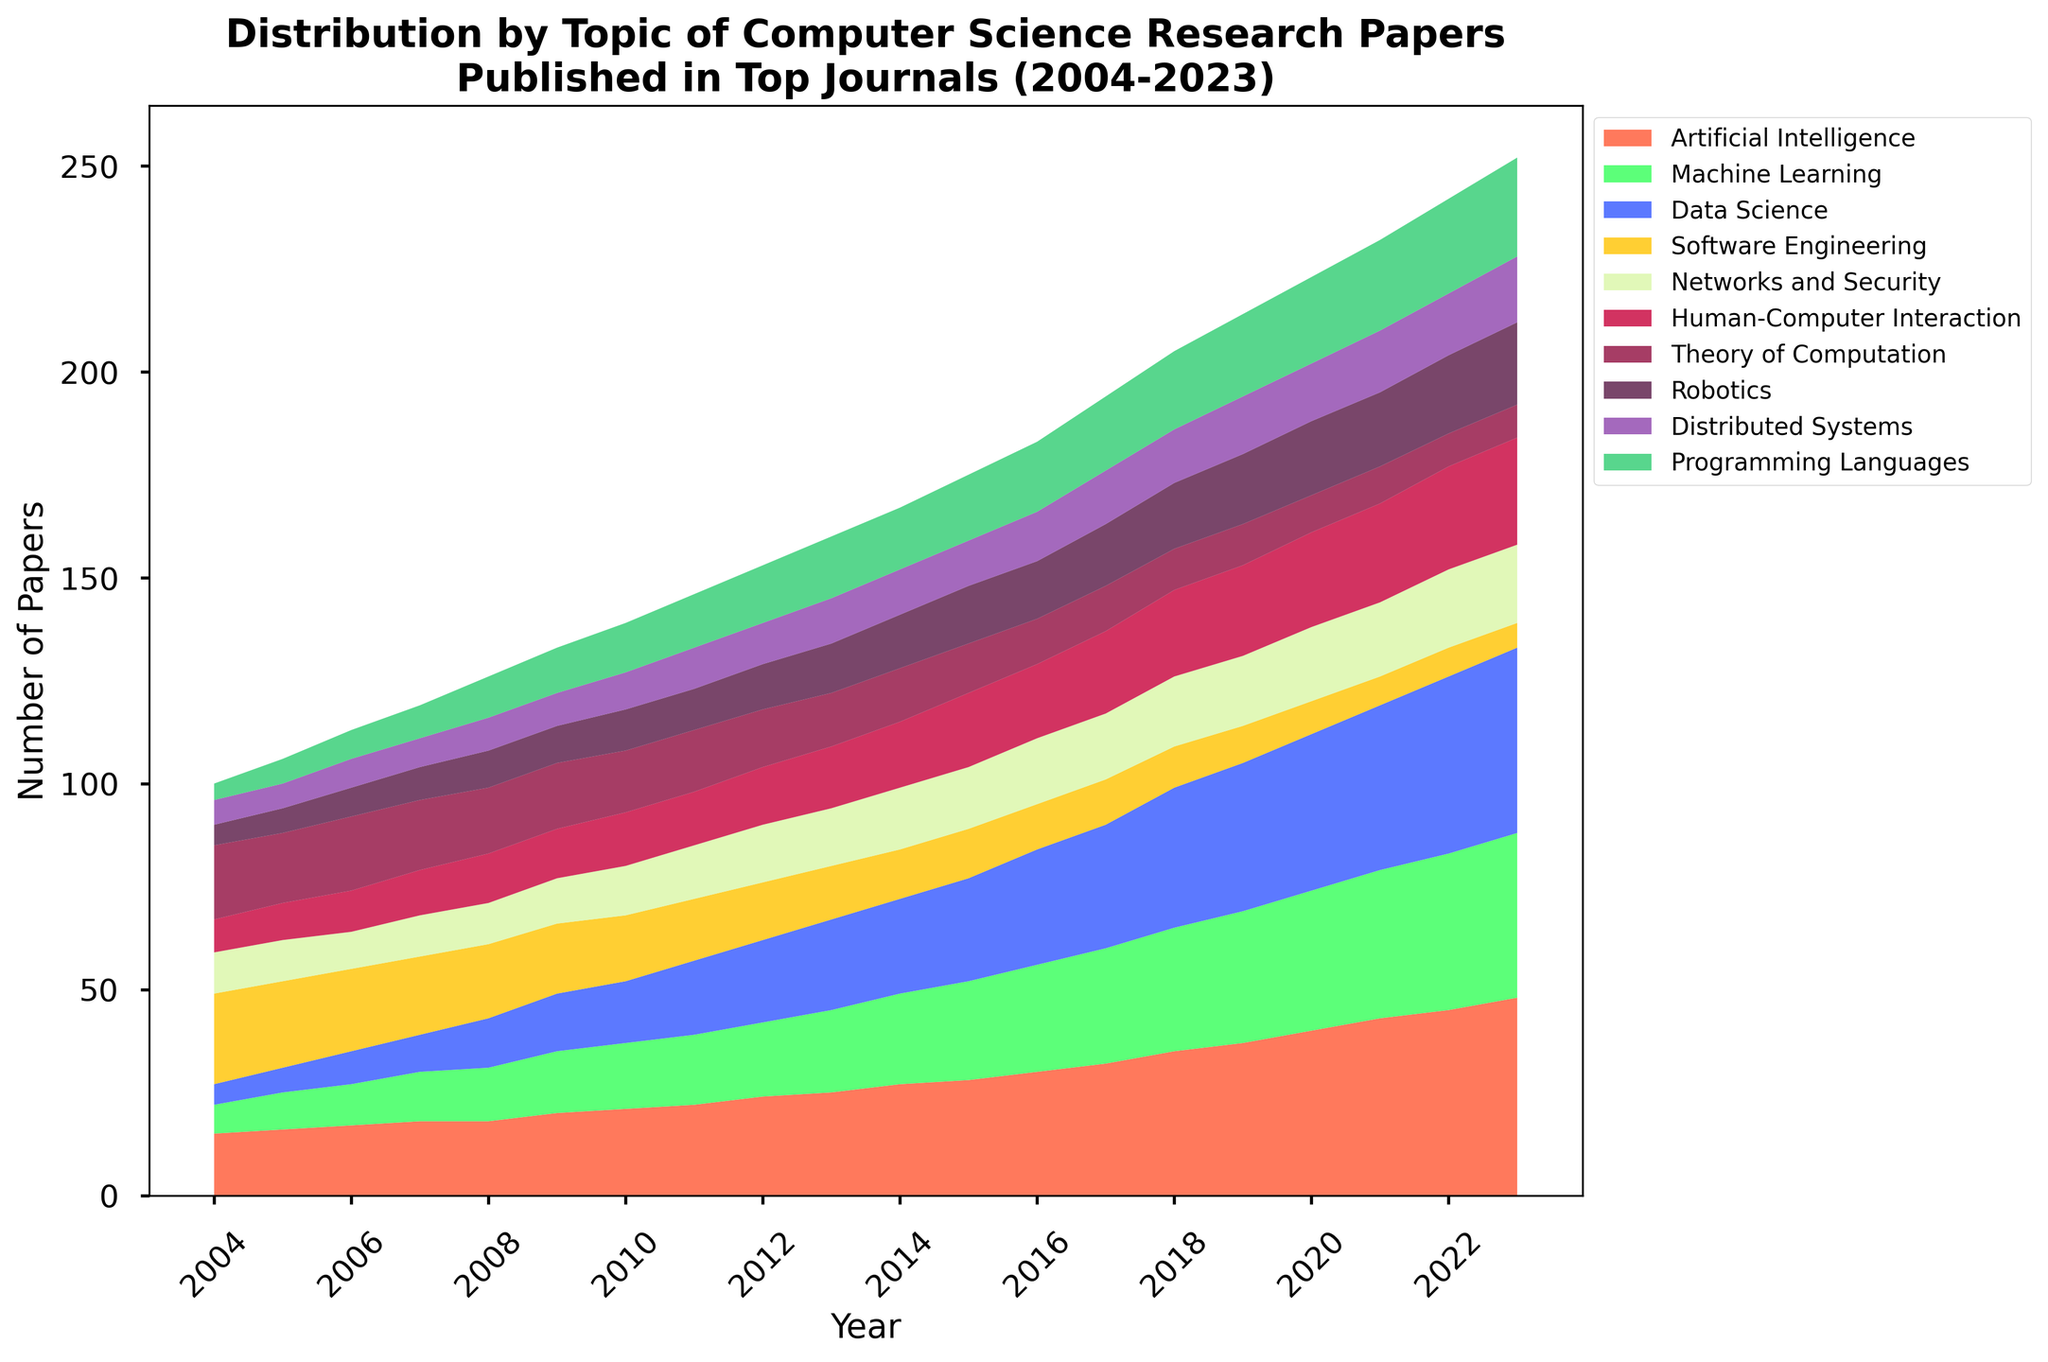What is the general trend in the number of papers related to Artificial Intelligence over the years? From 2004 to 2023, the number of papers related to Artificial Intelligence consistently increases each year, showing a clear upward trend. The values start at 15 in 2004 and rise to 48 in 2023.
Answer: Upward trend Has the number of Machine Learning papers increased more rapidly compared to Data Science papers from 2004 to 2023? At both the starting and ending years, it's evident that Machine Learning and Data Science papers have both increased significantly. Machine Learning started at 7 papers in 2004 and ended at 40 in 2023. Data Science started at 5 papers in 2004 and reached 45 in 2023. Although both show large increases, Data Science papers have increased slightly more rapidly than Machine Learning papers.
Answer: No What is the lowest point for Software Engineering papers, and in which year does it occur? The number of Software Engineering papers is lowest in 2023, where it drops to 6 papers. Analyzing the chart, it is clear that the value continuously declines from 22 in 2004 to its lowest point in 2023.
Answer: 2023 In which year do Human-Computer Interaction papers surpass Networks and Security papers for the first time? From 2004 to 2023, Human-Computer Interaction papers surpass Networks and Security papers for the first time in 2017. Human-Computer Interaction papers are at 20 while Networks and Security papers are at 16.
Answer: 2017 Which topic shows the most stability over the 20-year period, maintaining a relatively steady number of papers published each year? By observing the chart, Theory of Computation appears to maintain a relatively steady number of papers over the entire period with only a slight decrease, starting at 18 in 2004 and ending at 8 in 2023. Although it shows a general decline, it is less variable compared to other topics.
Answer: Theory of Computation Compare the number of Distributed Systems papers in 2004 and 2023. What is the difference, and which year has more papers? In 2004, there were 6 papers on Distributed Systems, and in 2023, the number increased to 16 papers. The difference is 16 - 6 = 10. Therefore, 2023 has more papers.
Answer: 10, 2023 Which topic had the highest increase in the number of published papers between 2004 and 2023? Observing the chart, Data Science shows the highest increase in the number of published papers, starting at 5 in 2004 and increasing to 45 in 2023, which is an increase of 40 papers.
Answer: Data Science What is the total number of papers published in 2015 across all topics? Summing up all the values for 2015: 28 (AI) + 24 (ML) + 25 (Data Science) + 12 (Software Engineering) + 15 (Networks and Security) + 18 (HCI) + 12 (Theory of Computation) + 14 (Robotics) + 11 (Distributed Systems) + 16 (Programming Languages) = 175.
Answer: 175 